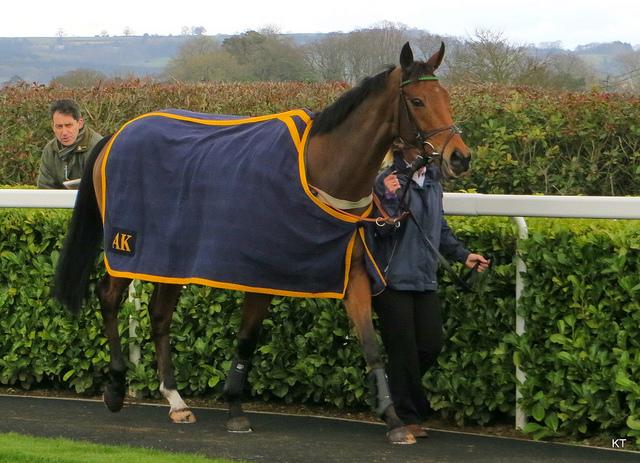What color is the animal in the picture?
Give a very brief answer. Brown. What color is the horse's blanket?
Concise answer only. Blue. What is the animal wearing?
Concise answer only. Blanket. Is someone trying to steal the horse?
Write a very short answer. No. Does it look rainy?
Keep it brief. Yes. 